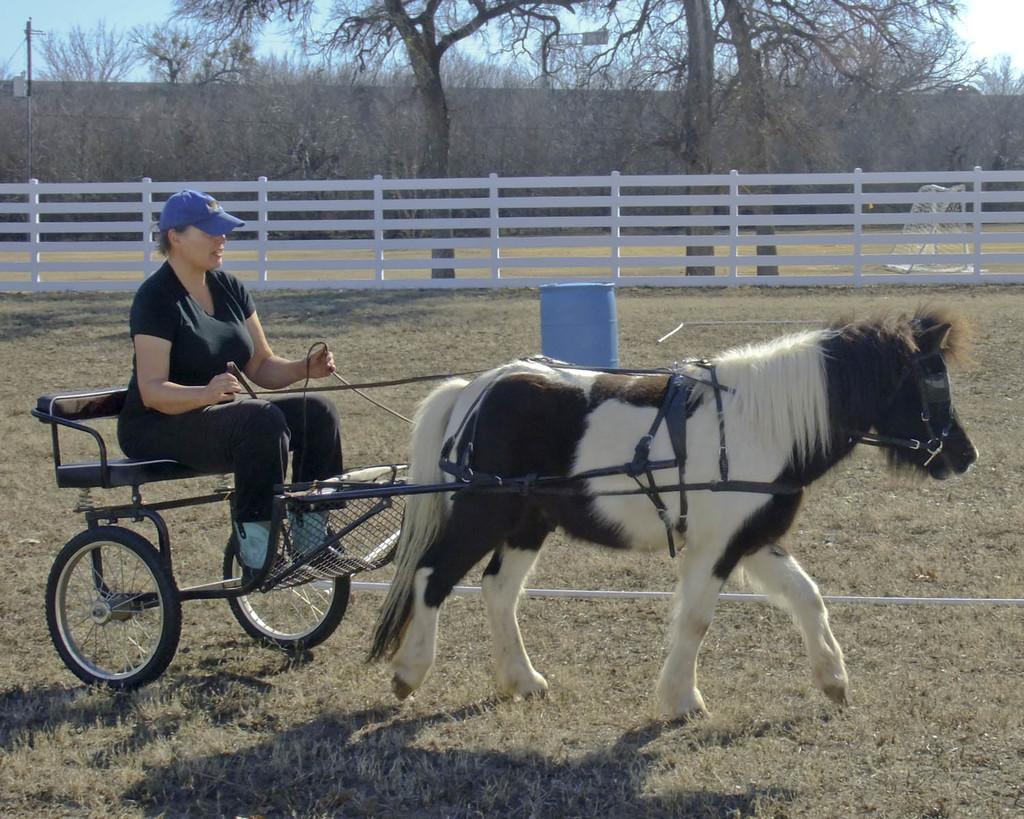In one or two sentences, can you explain what this image depicts? a person is riding a horse. behind her there is a drum and fencing. at the back there are trees. 